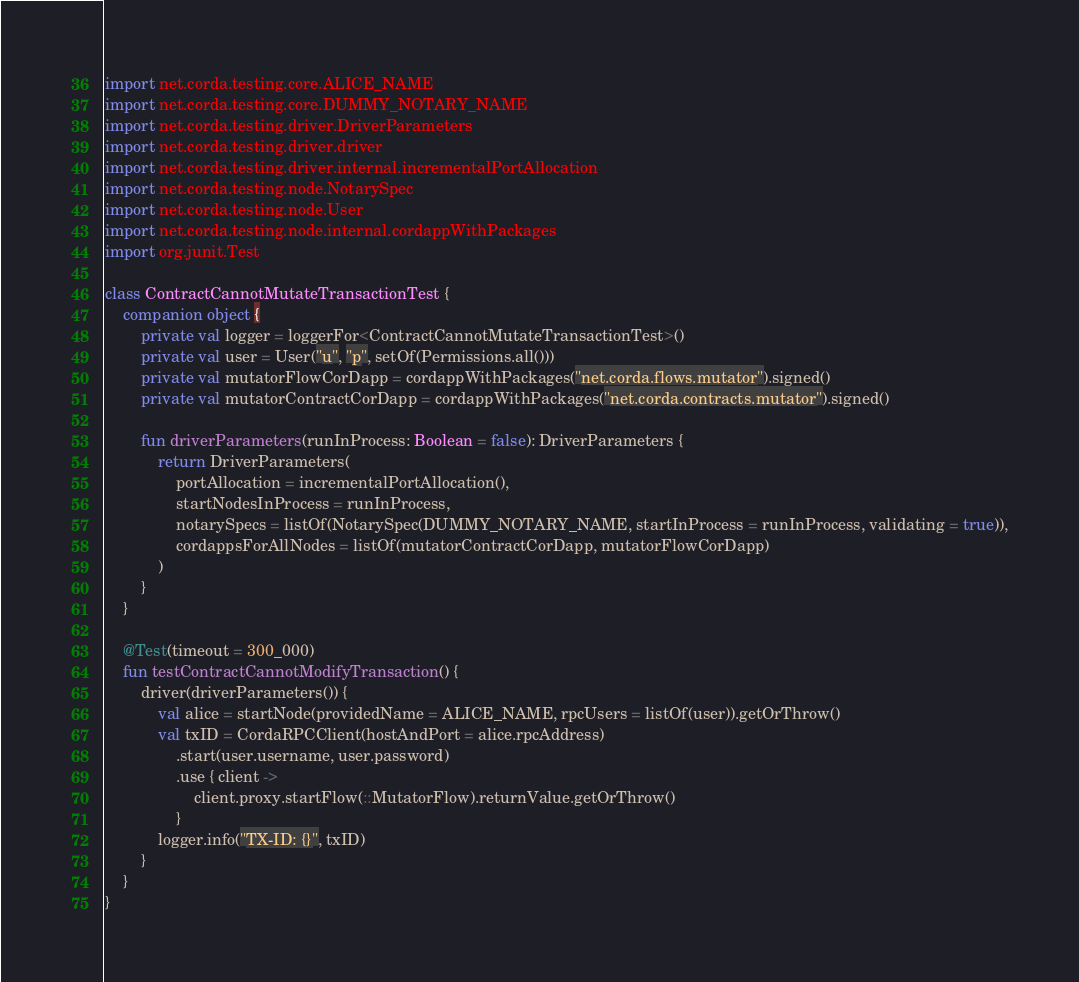<code> <loc_0><loc_0><loc_500><loc_500><_Kotlin_>import net.corda.testing.core.ALICE_NAME
import net.corda.testing.core.DUMMY_NOTARY_NAME
import net.corda.testing.driver.DriverParameters
import net.corda.testing.driver.driver
import net.corda.testing.driver.internal.incrementalPortAllocation
import net.corda.testing.node.NotarySpec
import net.corda.testing.node.User
import net.corda.testing.node.internal.cordappWithPackages
import org.junit.Test

class ContractCannotMutateTransactionTest {
    companion object {
        private val logger = loggerFor<ContractCannotMutateTransactionTest>()
        private val user = User("u", "p", setOf(Permissions.all()))
        private val mutatorFlowCorDapp = cordappWithPackages("net.corda.flows.mutator").signed()
        private val mutatorContractCorDapp = cordappWithPackages("net.corda.contracts.mutator").signed()

        fun driverParameters(runInProcess: Boolean = false): DriverParameters {
            return DriverParameters(
                portAllocation = incrementalPortAllocation(),
                startNodesInProcess = runInProcess,
                notarySpecs = listOf(NotarySpec(DUMMY_NOTARY_NAME, startInProcess = runInProcess, validating = true)),
                cordappsForAllNodes = listOf(mutatorContractCorDapp, mutatorFlowCorDapp)
            )
        }
    }

    @Test(timeout = 300_000)
    fun testContractCannotModifyTransaction() {
        driver(driverParameters()) {
            val alice = startNode(providedName = ALICE_NAME, rpcUsers = listOf(user)).getOrThrow()
            val txID = CordaRPCClient(hostAndPort = alice.rpcAddress)
                .start(user.username, user.password)
                .use { client ->
                    client.proxy.startFlow(::MutatorFlow).returnValue.getOrThrow()
                }
            logger.info("TX-ID: {}", txID)
        }
    }
}
</code> 